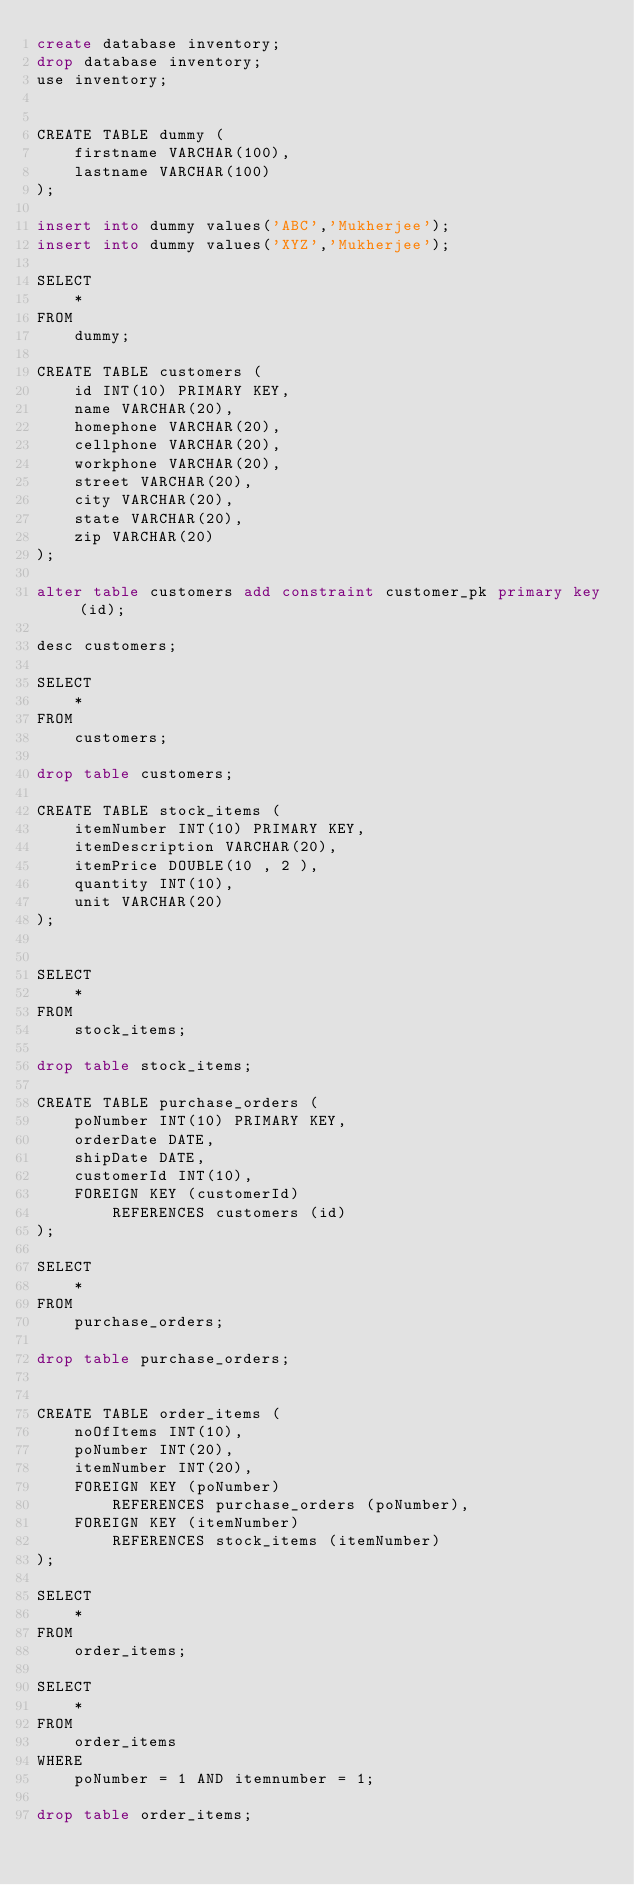Convert code to text. <code><loc_0><loc_0><loc_500><loc_500><_SQL_>create database inventory;
drop database inventory;
use inventory;


CREATE TABLE dummy (
    firstname VARCHAR(100),
    lastname VARCHAR(100)
);

insert into dummy values('ABC','Mukherjee');
insert into dummy values('XYZ','Mukherjee');

SELECT 
    *
FROM
    dummy;

CREATE TABLE customers (
    id INT(10) PRIMARY KEY,
    name VARCHAR(20),
    homephone VARCHAR(20),
    cellphone VARCHAR(20),
    workphone VARCHAR(20),
    street VARCHAR(20),
    city VARCHAR(20),
    state VARCHAR(20),
    zip VARCHAR(20)
);

alter table customers add constraint customer_pk primary key (id);

desc customers;

SELECT 
    *
FROM
    customers;

drop table customers;

CREATE TABLE stock_items (
    itemNumber INT(10) PRIMARY KEY,
    itemDescription VARCHAR(20),
    itemPrice DOUBLE(10 , 2 ),
    quantity INT(10),
    unit VARCHAR(20)
);


SELECT 
    *
FROM
    stock_items;
    
drop table stock_items;

CREATE TABLE purchase_orders (
    poNumber INT(10) PRIMARY KEY,
    orderDate DATE,
    shipDate DATE,
    customerId INT(10),
    FOREIGN KEY (customerId)
        REFERENCES customers (id)
);

SELECT 
    *
FROM
    purchase_orders;

drop table purchase_orders;


CREATE TABLE order_items (
    noOfItems INT(10),
    poNumber INT(20),
    itemNumber INT(20),
    FOREIGN KEY (poNumber)
        REFERENCES purchase_orders (poNumber),
    FOREIGN KEY (itemNumber)
        REFERENCES stock_items (itemNumber)
);

SELECT 
    *
FROM
    order_items;
    
SELECT 
    *
FROM
    order_items
WHERE
    poNumber = 1 AND itemnumber = 1;

drop table order_items;</code> 